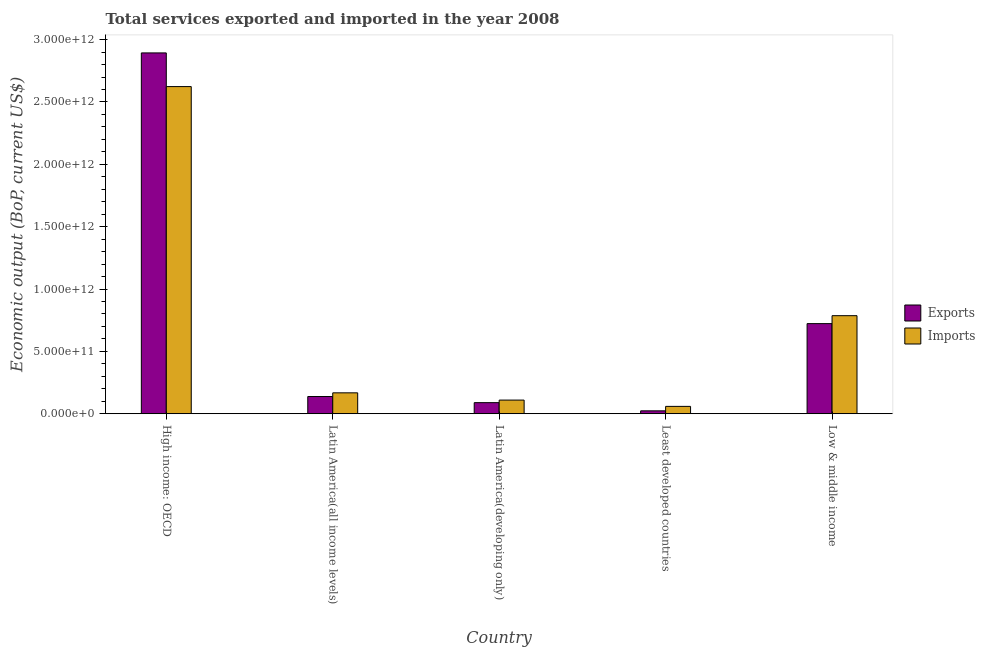How many different coloured bars are there?
Your answer should be very brief. 2. How many groups of bars are there?
Your answer should be compact. 5. Are the number of bars per tick equal to the number of legend labels?
Your answer should be compact. Yes. Are the number of bars on each tick of the X-axis equal?
Make the answer very short. Yes. How many bars are there on the 5th tick from the right?
Offer a very short reply. 2. What is the label of the 2nd group of bars from the left?
Your answer should be very brief. Latin America(all income levels). In how many cases, is the number of bars for a given country not equal to the number of legend labels?
Your answer should be very brief. 0. What is the amount of service imports in Low & middle income?
Your response must be concise. 7.86e+11. Across all countries, what is the maximum amount of service exports?
Ensure brevity in your answer.  2.89e+12. Across all countries, what is the minimum amount of service imports?
Keep it short and to the point. 5.89e+1. In which country was the amount of service imports maximum?
Your answer should be very brief. High income: OECD. In which country was the amount of service exports minimum?
Provide a succinct answer. Least developed countries. What is the total amount of service exports in the graph?
Offer a terse response. 3.87e+12. What is the difference between the amount of service exports in Least developed countries and that in Low & middle income?
Ensure brevity in your answer.  -6.99e+11. What is the difference between the amount of service exports in High income: OECD and the amount of service imports in Latin America(developing only)?
Keep it short and to the point. 2.78e+12. What is the average amount of service imports per country?
Offer a very short reply. 7.49e+11. What is the difference between the amount of service exports and amount of service imports in High income: OECD?
Give a very brief answer. 2.70e+11. In how many countries, is the amount of service imports greater than 600000000000 US$?
Your answer should be compact. 2. What is the ratio of the amount of service imports in High income: OECD to that in Low & middle income?
Provide a short and direct response. 3.34. Is the amount of service imports in Latin America(all income levels) less than that in Low & middle income?
Provide a short and direct response. Yes. Is the difference between the amount of service imports in Latin America(developing only) and Low & middle income greater than the difference between the amount of service exports in Latin America(developing only) and Low & middle income?
Ensure brevity in your answer.  No. What is the difference between the highest and the second highest amount of service imports?
Provide a short and direct response. 1.84e+12. What is the difference between the highest and the lowest amount of service exports?
Give a very brief answer. 2.87e+12. In how many countries, is the amount of service exports greater than the average amount of service exports taken over all countries?
Your answer should be compact. 1. What does the 2nd bar from the left in Latin America(all income levels) represents?
Offer a very short reply. Imports. What does the 2nd bar from the right in Latin America(all income levels) represents?
Offer a terse response. Exports. How many bars are there?
Keep it short and to the point. 10. Are all the bars in the graph horizontal?
Offer a terse response. No. How many countries are there in the graph?
Keep it short and to the point. 5. What is the difference between two consecutive major ticks on the Y-axis?
Your answer should be very brief. 5.00e+11. Are the values on the major ticks of Y-axis written in scientific E-notation?
Your response must be concise. Yes. Does the graph contain grids?
Your answer should be compact. No. How are the legend labels stacked?
Provide a succinct answer. Vertical. What is the title of the graph?
Make the answer very short. Total services exported and imported in the year 2008. Does "Investment in Telecom" appear as one of the legend labels in the graph?
Ensure brevity in your answer.  No. What is the label or title of the Y-axis?
Provide a succinct answer. Economic output (BoP, current US$). What is the Economic output (BoP, current US$) in Exports in High income: OECD?
Keep it short and to the point. 2.89e+12. What is the Economic output (BoP, current US$) in Imports in High income: OECD?
Your answer should be very brief. 2.62e+12. What is the Economic output (BoP, current US$) of Exports in Latin America(all income levels)?
Your answer should be very brief. 1.38e+11. What is the Economic output (BoP, current US$) in Imports in Latin America(all income levels)?
Provide a short and direct response. 1.68e+11. What is the Economic output (BoP, current US$) in Exports in Latin America(developing only)?
Ensure brevity in your answer.  8.89e+1. What is the Economic output (BoP, current US$) of Imports in Latin America(developing only)?
Offer a terse response. 1.09e+11. What is the Economic output (BoP, current US$) in Exports in Least developed countries?
Offer a very short reply. 2.33e+1. What is the Economic output (BoP, current US$) of Imports in Least developed countries?
Make the answer very short. 5.89e+1. What is the Economic output (BoP, current US$) in Exports in Low & middle income?
Ensure brevity in your answer.  7.23e+11. What is the Economic output (BoP, current US$) in Imports in Low & middle income?
Keep it short and to the point. 7.86e+11. Across all countries, what is the maximum Economic output (BoP, current US$) in Exports?
Offer a very short reply. 2.89e+12. Across all countries, what is the maximum Economic output (BoP, current US$) of Imports?
Make the answer very short. 2.62e+12. Across all countries, what is the minimum Economic output (BoP, current US$) of Exports?
Make the answer very short. 2.33e+1. Across all countries, what is the minimum Economic output (BoP, current US$) of Imports?
Give a very brief answer. 5.89e+1. What is the total Economic output (BoP, current US$) in Exports in the graph?
Ensure brevity in your answer.  3.87e+12. What is the total Economic output (BoP, current US$) in Imports in the graph?
Keep it short and to the point. 3.75e+12. What is the difference between the Economic output (BoP, current US$) of Exports in High income: OECD and that in Latin America(all income levels)?
Your answer should be compact. 2.76e+12. What is the difference between the Economic output (BoP, current US$) of Imports in High income: OECD and that in Latin America(all income levels)?
Your answer should be compact. 2.46e+12. What is the difference between the Economic output (BoP, current US$) of Exports in High income: OECD and that in Latin America(developing only)?
Your answer should be compact. 2.80e+12. What is the difference between the Economic output (BoP, current US$) in Imports in High income: OECD and that in Latin America(developing only)?
Your response must be concise. 2.51e+12. What is the difference between the Economic output (BoP, current US$) in Exports in High income: OECD and that in Least developed countries?
Your response must be concise. 2.87e+12. What is the difference between the Economic output (BoP, current US$) of Imports in High income: OECD and that in Least developed countries?
Your answer should be compact. 2.56e+12. What is the difference between the Economic output (BoP, current US$) in Exports in High income: OECD and that in Low & middle income?
Give a very brief answer. 2.17e+12. What is the difference between the Economic output (BoP, current US$) of Imports in High income: OECD and that in Low & middle income?
Give a very brief answer. 1.84e+12. What is the difference between the Economic output (BoP, current US$) of Exports in Latin America(all income levels) and that in Latin America(developing only)?
Keep it short and to the point. 4.92e+1. What is the difference between the Economic output (BoP, current US$) of Imports in Latin America(all income levels) and that in Latin America(developing only)?
Give a very brief answer. 5.82e+1. What is the difference between the Economic output (BoP, current US$) in Exports in Latin America(all income levels) and that in Least developed countries?
Provide a short and direct response. 1.15e+11. What is the difference between the Economic output (BoP, current US$) of Imports in Latin America(all income levels) and that in Least developed countries?
Offer a terse response. 1.09e+11. What is the difference between the Economic output (BoP, current US$) in Exports in Latin America(all income levels) and that in Low & middle income?
Make the answer very short. -5.85e+11. What is the difference between the Economic output (BoP, current US$) of Imports in Latin America(all income levels) and that in Low & middle income?
Your answer should be compact. -6.19e+11. What is the difference between the Economic output (BoP, current US$) in Exports in Latin America(developing only) and that in Least developed countries?
Your answer should be very brief. 6.56e+1. What is the difference between the Economic output (BoP, current US$) of Imports in Latin America(developing only) and that in Least developed countries?
Make the answer very short. 5.05e+1. What is the difference between the Economic output (BoP, current US$) in Exports in Latin America(developing only) and that in Low & middle income?
Give a very brief answer. -6.34e+11. What is the difference between the Economic output (BoP, current US$) in Imports in Latin America(developing only) and that in Low & middle income?
Provide a succinct answer. -6.77e+11. What is the difference between the Economic output (BoP, current US$) in Exports in Least developed countries and that in Low & middle income?
Provide a succinct answer. -6.99e+11. What is the difference between the Economic output (BoP, current US$) in Imports in Least developed countries and that in Low & middle income?
Your answer should be very brief. -7.27e+11. What is the difference between the Economic output (BoP, current US$) of Exports in High income: OECD and the Economic output (BoP, current US$) of Imports in Latin America(all income levels)?
Your response must be concise. 2.73e+12. What is the difference between the Economic output (BoP, current US$) of Exports in High income: OECD and the Economic output (BoP, current US$) of Imports in Latin America(developing only)?
Make the answer very short. 2.78e+12. What is the difference between the Economic output (BoP, current US$) in Exports in High income: OECD and the Economic output (BoP, current US$) in Imports in Least developed countries?
Ensure brevity in your answer.  2.83e+12. What is the difference between the Economic output (BoP, current US$) in Exports in High income: OECD and the Economic output (BoP, current US$) in Imports in Low & middle income?
Ensure brevity in your answer.  2.11e+12. What is the difference between the Economic output (BoP, current US$) in Exports in Latin America(all income levels) and the Economic output (BoP, current US$) in Imports in Latin America(developing only)?
Your response must be concise. 2.86e+1. What is the difference between the Economic output (BoP, current US$) in Exports in Latin America(all income levels) and the Economic output (BoP, current US$) in Imports in Least developed countries?
Your answer should be compact. 7.92e+1. What is the difference between the Economic output (BoP, current US$) of Exports in Latin America(all income levels) and the Economic output (BoP, current US$) of Imports in Low & middle income?
Your answer should be compact. -6.48e+11. What is the difference between the Economic output (BoP, current US$) in Exports in Latin America(developing only) and the Economic output (BoP, current US$) in Imports in Least developed countries?
Provide a succinct answer. 3.00e+1. What is the difference between the Economic output (BoP, current US$) in Exports in Latin America(developing only) and the Economic output (BoP, current US$) in Imports in Low & middle income?
Make the answer very short. -6.97e+11. What is the difference between the Economic output (BoP, current US$) of Exports in Least developed countries and the Economic output (BoP, current US$) of Imports in Low & middle income?
Offer a terse response. -7.63e+11. What is the average Economic output (BoP, current US$) of Exports per country?
Make the answer very short. 7.73e+11. What is the average Economic output (BoP, current US$) in Imports per country?
Offer a terse response. 7.49e+11. What is the difference between the Economic output (BoP, current US$) of Exports and Economic output (BoP, current US$) of Imports in High income: OECD?
Provide a succinct answer. 2.70e+11. What is the difference between the Economic output (BoP, current US$) in Exports and Economic output (BoP, current US$) in Imports in Latin America(all income levels)?
Your response must be concise. -2.95e+1. What is the difference between the Economic output (BoP, current US$) of Exports and Economic output (BoP, current US$) of Imports in Latin America(developing only)?
Provide a succinct answer. -2.05e+1. What is the difference between the Economic output (BoP, current US$) in Exports and Economic output (BoP, current US$) in Imports in Least developed countries?
Offer a very short reply. -3.57e+1. What is the difference between the Economic output (BoP, current US$) of Exports and Economic output (BoP, current US$) of Imports in Low & middle income?
Your response must be concise. -6.37e+1. What is the ratio of the Economic output (BoP, current US$) of Exports in High income: OECD to that in Latin America(all income levels)?
Provide a short and direct response. 20.95. What is the ratio of the Economic output (BoP, current US$) of Imports in High income: OECD to that in Latin America(all income levels)?
Offer a very short reply. 15.65. What is the ratio of the Economic output (BoP, current US$) in Exports in High income: OECD to that in Latin America(developing only)?
Offer a very short reply. 32.54. What is the ratio of the Economic output (BoP, current US$) in Imports in High income: OECD to that in Latin America(developing only)?
Make the answer very short. 23.97. What is the ratio of the Economic output (BoP, current US$) in Exports in High income: OECD to that in Least developed countries?
Keep it short and to the point. 124.28. What is the ratio of the Economic output (BoP, current US$) in Imports in High income: OECD to that in Least developed countries?
Ensure brevity in your answer.  44.51. What is the ratio of the Economic output (BoP, current US$) of Exports in High income: OECD to that in Low & middle income?
Make the answer very short. 4. What is the ratio of the Economic output (BoP, current US$) in Imports in High income: OECD to that in Low & middle income?
Your answer should be compact. 3.34. What is the ratio of the Economic output (BoP, current US$) in Exports in Latin America(all income levels) to that in Latin America(developing only)?
Your response must be concise. 1.55. What is the ratio of the Economic output (BoP, current US$) of Imports in Latin America(all income levels) to that in Latin America(developing only)?
Provide a succinct answer. 1.53. What is the ratio of the Economic output (BoP, current US$) in Exports in Latin America(all income levels) to that in Least developed countries?
Offer a terse response. 5.93. What is the ratio of the Economic output (BoP, current US$) in Imports in Latin America(all income levels) to that in Least developed countries?
Make the answer very short. 2.84. What is the ratio of the Economic output (BoP, current US$) in Exports in Latin America(all income levels) to that in Low & middle income?
Provide a succinct answer. 0.19. What is the ratio of the Economic output (BoP, current US$) of Imports in Latin America(all income levels) to that in Low & middle income?
Your response must be concise. 0.21. What is the ratio of the Economic output (BoP, current US$) of Exports in Latin America(developing only) to that in Least developed countries?
Provide a short and direct response. 3.82. What is the ratio of the Economic output (BoP, current US$) in Imports in Latin America(developing only) to that in Least developed countries?
Provide a short and direct response. 1.86. What is the ratio of the Economic output (BoP, current US$) of Exports in Latin America(developing only) to that in Low & middle income?
Offer a terse response. 0.12. What is the ratio of the Economic output (BoP, current US$) of Imports in Latin America(developing only) to that in Low & middle income?
Ensure brevity in your answer.  0.14. What is the ratio of the Economic output (BoP, current US$) of Exports in Least developed countries to that in Low & middle income?
Give a very brief answer. 0.03. What is the ratio of the Economic output (BoP, current US$) of Imports in Least developed countries to that in Low & middle income?
Provide a short and direct response. 0.07. What is the difference between the highest and the second highest Economic output (BoP, current US$) in Exports?
Provide a short and direct response. 2.17e+12. What is the difference between the highest and the second highest Economic output (BoP, current US$) of Imports?
Make the answer very short. 1.84e+12. What is the difference between the highest and the lowest Economic output (BoP, current US$) of Exports?
Your response must be concise. 2.87e+12. What is the difference between the highest and the lowest Economic output (BoP, current US$) in Imports?
Make the answer very short. 2.56e+12. 